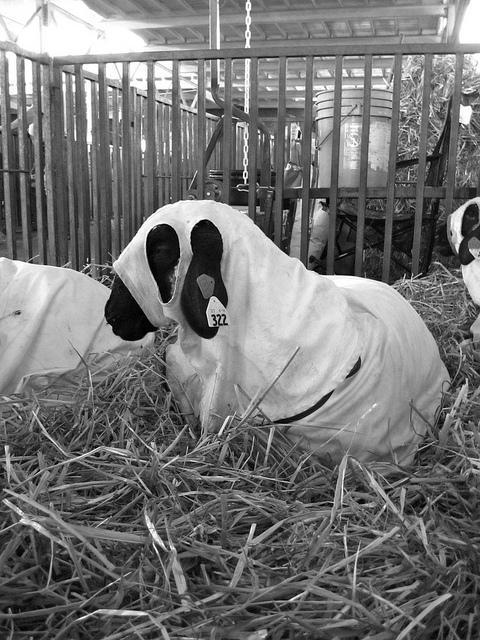How many sheep are in the photo?
Give a very brief answer. 3. 